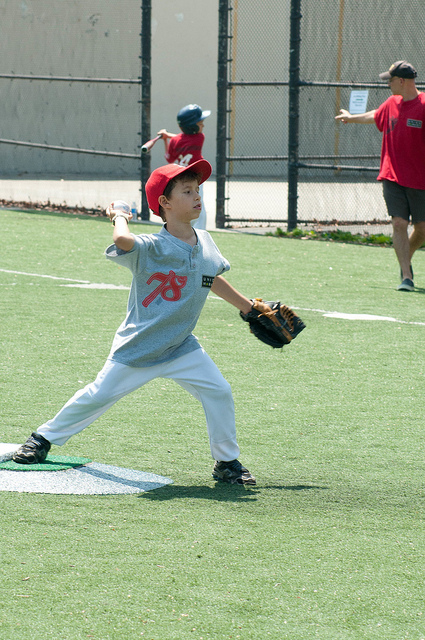Identify the text contained in this image. 78 